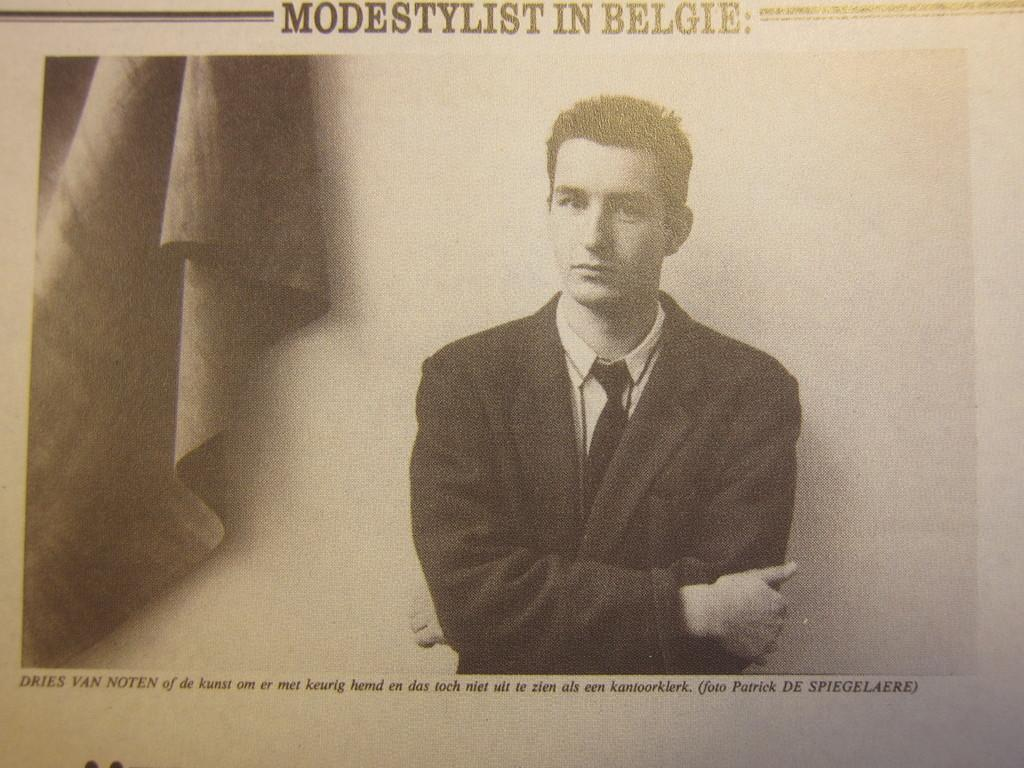What is the main subject of the paper in the image? The paper contains an image of a person. Are there any other images on the paper besides the person? Yes, there is an image of cloth on the paper. Is there any text present on the paper? Yes, there is text on the paper. What is the taste of the frame around the image? There is no frame present in the image, and therefore no taste can be associated with it. 